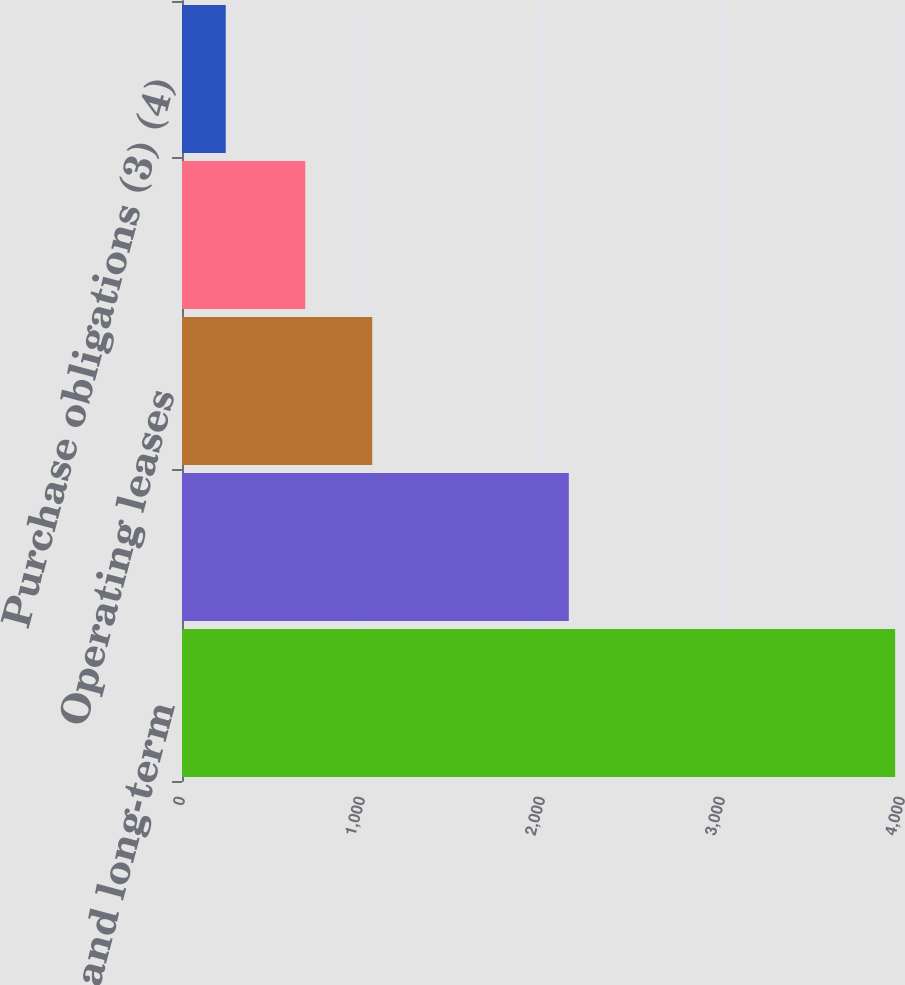<chart> <loc_0><loc_0><loc_500><loc_500><bar_chart><fcel>Short- and long-term<fcel>Interest expense on debt<fcel>Operating leases<fcel>Pension and other<fcel>Purchase obligations (3) (4)<nl><fcel>3962<fcel>2149<fcel>1056.9<fcel>685<fcel>243<nl></chart> 